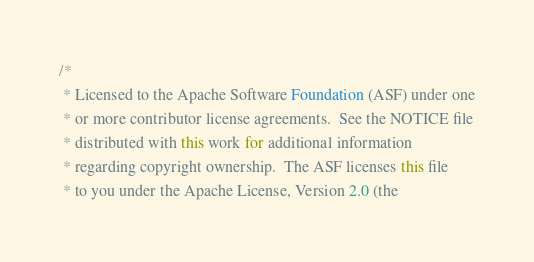Convert code to text. <code><loc_0><loc_0><loc_500><loc_500><_Java_>/* 
 * Licensed to the Apache Software Foundation (ASF) under one
 * or more contributor license agreements.  See the NOTICE file
 * distributed with this work for additional information
 * regarding copyright ownership.  The ASF licenses this file
 * to you under the Apache License, Version 2.0 (the</code> 